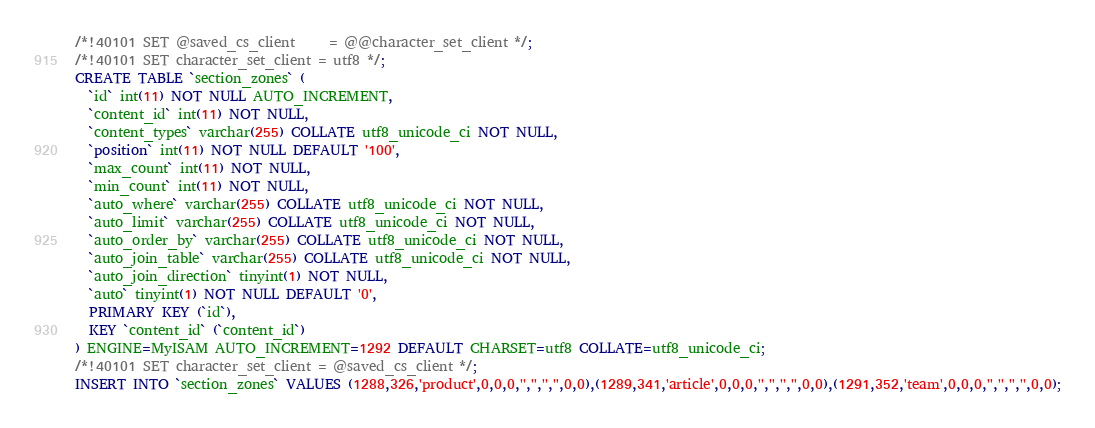Convert code to text. <code><loc_0><loc_0><loc_500><loc_500><_SQL_>/*!40101 SET @saved_cs_client     = @@character_set_client */;
/*!40101 SET character_set_client = utf8 */;
CREATE TABLE `section_zones` (
  `id` int(11) NOT NULL AUTO_INCREMENT,
  `content_id` int(11) NOT NULL,
  `content_types` varchar(255) COLLATE utf8_unicode_ci NOT NULL,
  `position` int(11) NOT NULL DEFAULT '100',
  `max_count` int(11) NOT NULL,
  `min_count` int(11) NOT NULL,
  `auto_where` varchar(255) COLLATE utf8_unicode_ci NOT NULL,
  `auto_limit` varchar(255) COLLATE utf8_unicode_ci NOT NULL,
  `auto_order_by` varchar(255) COLLATE utf8_unicode_ci NOT NULL,
  `auto_join_table` varchar(255) COLLATE utf8_unicode_ci NOT NULL,
  `auto_join_direction` tinyint(1) NOT NULL,
  `auto` tinyint(1) NOT NULL DEFAULT '0',
  PRIMARY KEY (`id`),
  KEY `content_id` (`content_id`)
) ENGINE=MyISAM AUTO_INCREMENT=1292 DEFAULT CHARSET=utf8 COLLATE=utf8_unicode_ci;
/*!40101 SET character_set_client = @saved_cs_client */;
INSERT INTO `section_zones` VALUES (1288,326,'product',0,0,0,'','','','',0,0),(1289,341,'article',0,0,0,'','','','',0,0),(1291,352,'team',0,0,0,'','','','',0,0);
</code> 